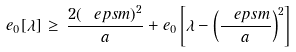Convert formula to latex. <formula><loc_0><loc_0><loc_500><loc_500>e _ { 0 } [ \lambda ] \, \geq \, \frac { 2 ( \ e p s m ) ^ { 2 } } { a } + e _ { 0 } \left [ \lambda - \left ( \frac { \ e p s m } { a } \right ) ^ { 2 } \right ]</formula> 